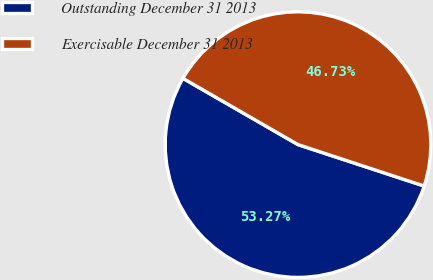<chart> <loc_0><loc_0><loc_500><loc_500><pie_chart><fcel>Outstanding December 31 2013<fcel>Exercisable December 31 2013<nl><fcel>53.27%<fcel>46.73%<nl></chart> 